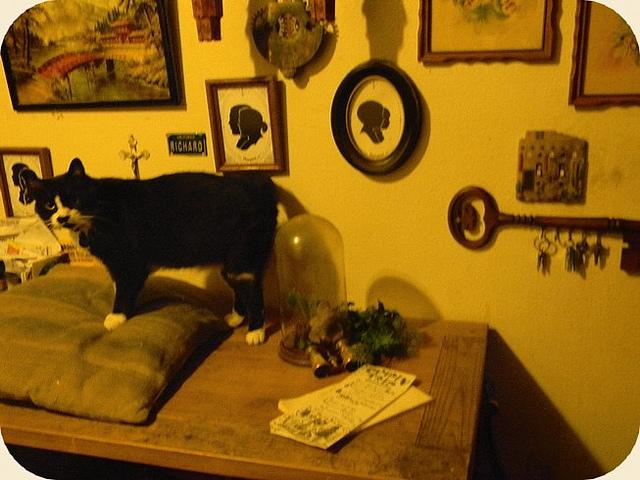What color is the cat?
Give a very brief answer. Black and white. Could the cat be allowed on the pillow?
Quick response, please. Yes. Is there keys on the wall?
Be succinct. Yes. 